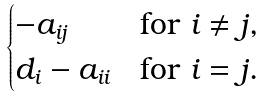Convert formula to latex. <formula><loc_0><loc_0><loc_500><loc_500>\begin{cases} - a _ { i j } & \text {for $i \neq j$,} \\ d _ { i } - a _ { i i } & \text {for $i = j$.} \end{cases}</formula> 